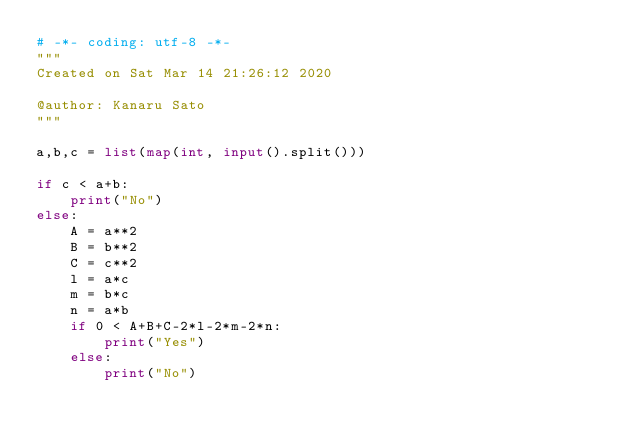<code> <loc_0><loc_0><loc_500><loc_500><_Python_># -*- coding: utf-8 -*-
"""
Created on Sat Mar 14 21:26:12 2020

@author: Kanaru Sato
"""

a,b,c = list(map(int, input().split()))

if c < a+b:
    print("No")
else:
    A = a**2
    B = b**2
    C = c**2
    l = a*c
    m = b*c
    n = a*b
    if 0 < A+B+C-2*l-2*m-2*n:
        print("Yes")
    else:
        print("No")</code> 